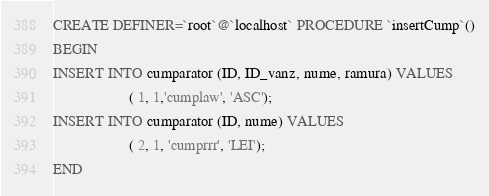Convert code to text. <code><loc_0><loc_0><loc_500><loc_500><_SQL_>CREATE DEFINER=`root`@`localhost` PROCEDURE `insertCump`()
BEGIN
INSERT INTO cumparator (ID, ID_vanz, nume, ramura) VALUES 
					( 1, 1,'cumplaw', 'ASC');
INSERT INTO cumparator (ID, nume) VALUES 
					( 2, 1, 'cumprrr', 'LEI');
END</code> 